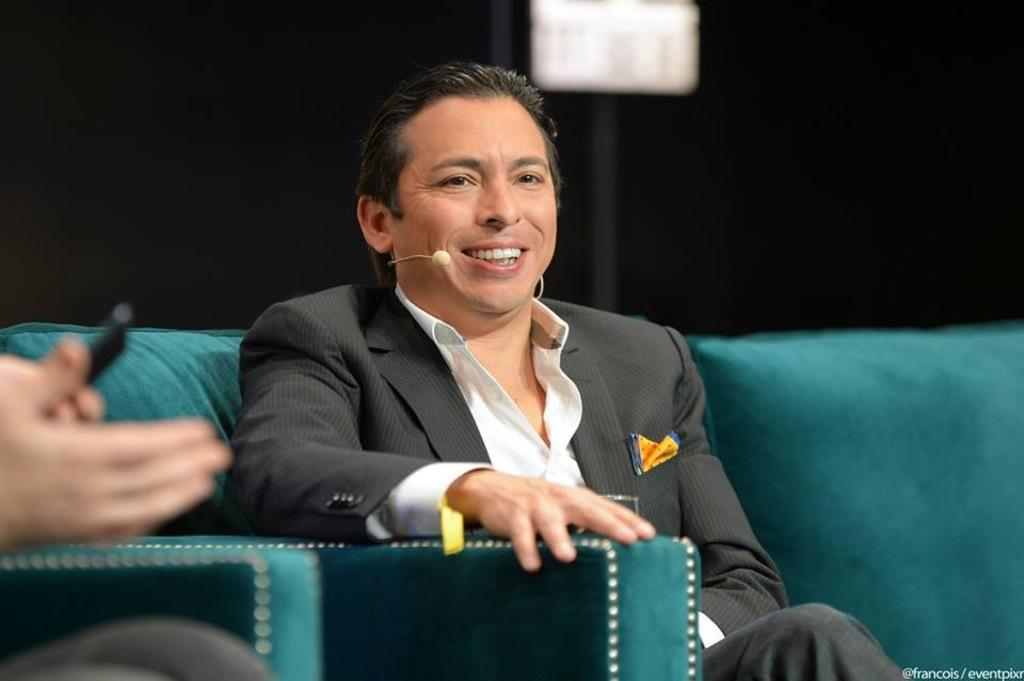How many people are in the image? There are two persons in the image. What are the people doing in the image? The two persons are sitting on a sofa. What can be inferred about the lighting in the image? The background appears to be dark. Can you describe the setting of the image? The image may have been taken in a hall. What type of spade is being used by the person on the left in the image? There is no spade present in the image; it features two people sitting on a sofa. How does the sleet affect the appearance of the sofa in the image? There is no sleet present in the image, and therefore it cannot affect the appearance of the sofa. 